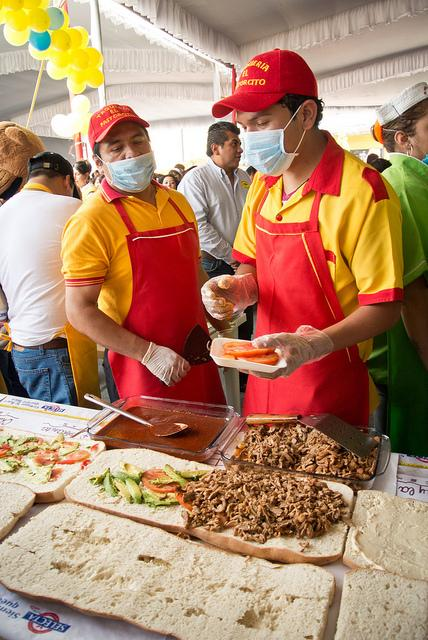These people are making what kind of food?

Choices:
A) mexican
B) halal
C) kosher
D) chinese mexican 